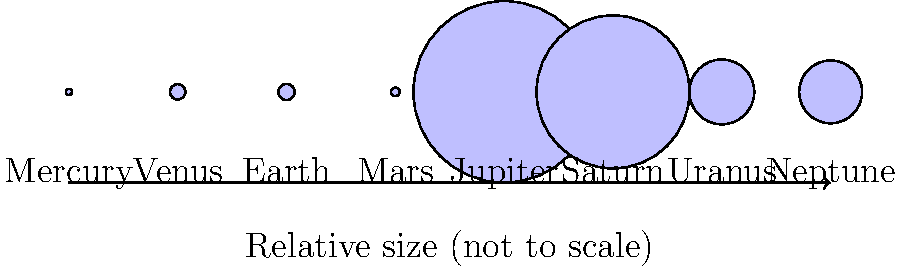In the context of planetary scales, which could be an intriguing analogy for comparing Jupiter to Earth in a dramatic opera setting? To answer this question, let's analyze the relative sizes of Jupiter and Earth:

1. From the diagram, we can see that Jupiter is significantly larger than Earth.
2. The actual diameters are:
   - Jupiter: 142,984 km
   - Earth: 12,756 km
3. To calculate the ratio:
   $\frac{\text{Jupiter's diameter}}{\text{Earth's diameter}} = \frac{142,984}{12,756} \approx 11.21$
4. This means Jupiter is about 11.21 times wider than Earth.
5. In opera terms, we could compare this to the difference between a grand opera house stage and a solo performer.
6. A typical grand opera stage might be around 100 feet wide, while a solo performer might occupy about 3 feet of space.
7. The ratio of 100:3 is approximately 33:1, which is larger than the Jupiter-Earth ratio but conceptually similar.

Therefore, an operatic analogy could be that Jupiter is like the entire grand stage, while Earth is like a solo performer standing on that stage. This comparison emphasizes the vast difference in size while using familiar concepts from the world of opera.
Answer: Jupiter is to Earth as a grand opera stage is to a solo performer. 